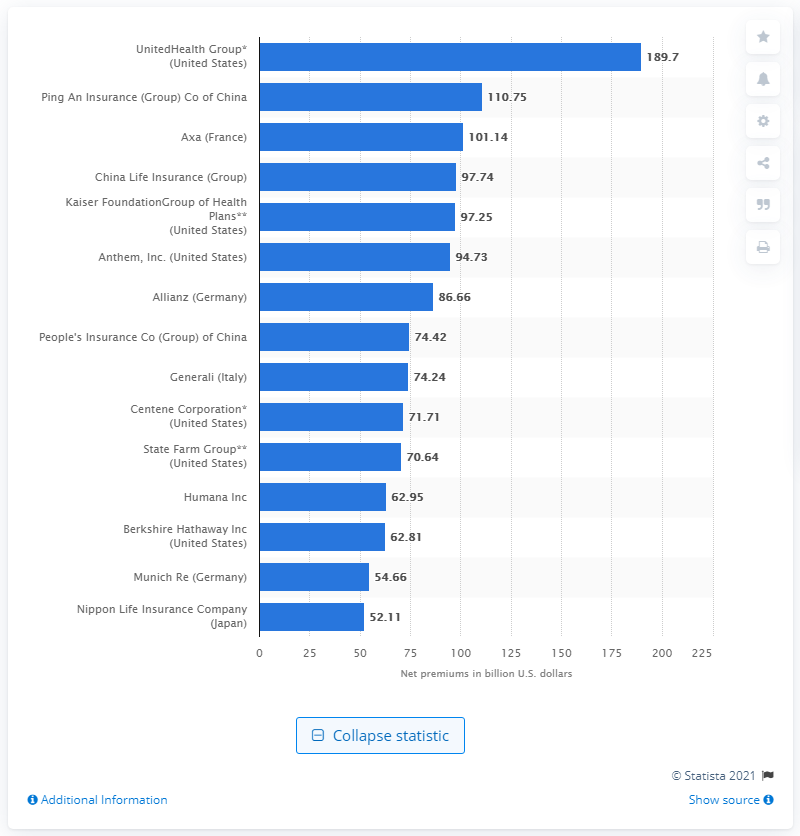Highlight a few significant elements in this photo. In 2019, the net premiums written by UnitedHealth Group were approximately $189.7 billion. 